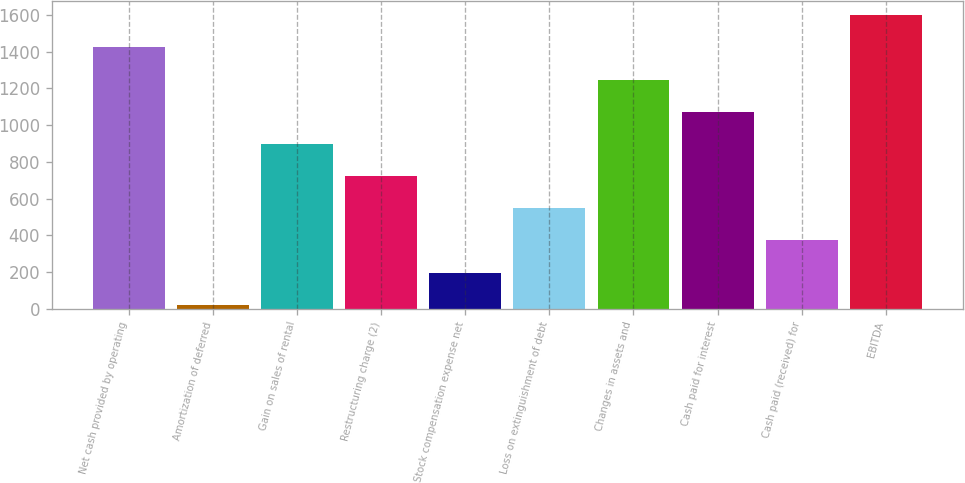Convert chart to OTSL. <chart><loc_0><loc_0><loc_500><loc_500><bar_chart><fcel>Net cash provided by operating<fcel>Amortization of deferred<fcel>Gain on sales of rental<fcel>Restructuring charge (2)<fcel>Stock compensation expense net<fcel>Loss on extinguishment of debt<fcel>Changes in assets and<fcel>Cash paid for interest<fcel>Cash paid (received) for<fcel>EBITDA<nl><fcel>1422.2<fcel>23<fcel>897.5<fcel>722.6<fcel>197.9<fcel>547.7<fcel>1247.3<fcel>1072.4<fcel>372.8<fcel>1597.1<nl></chart> 